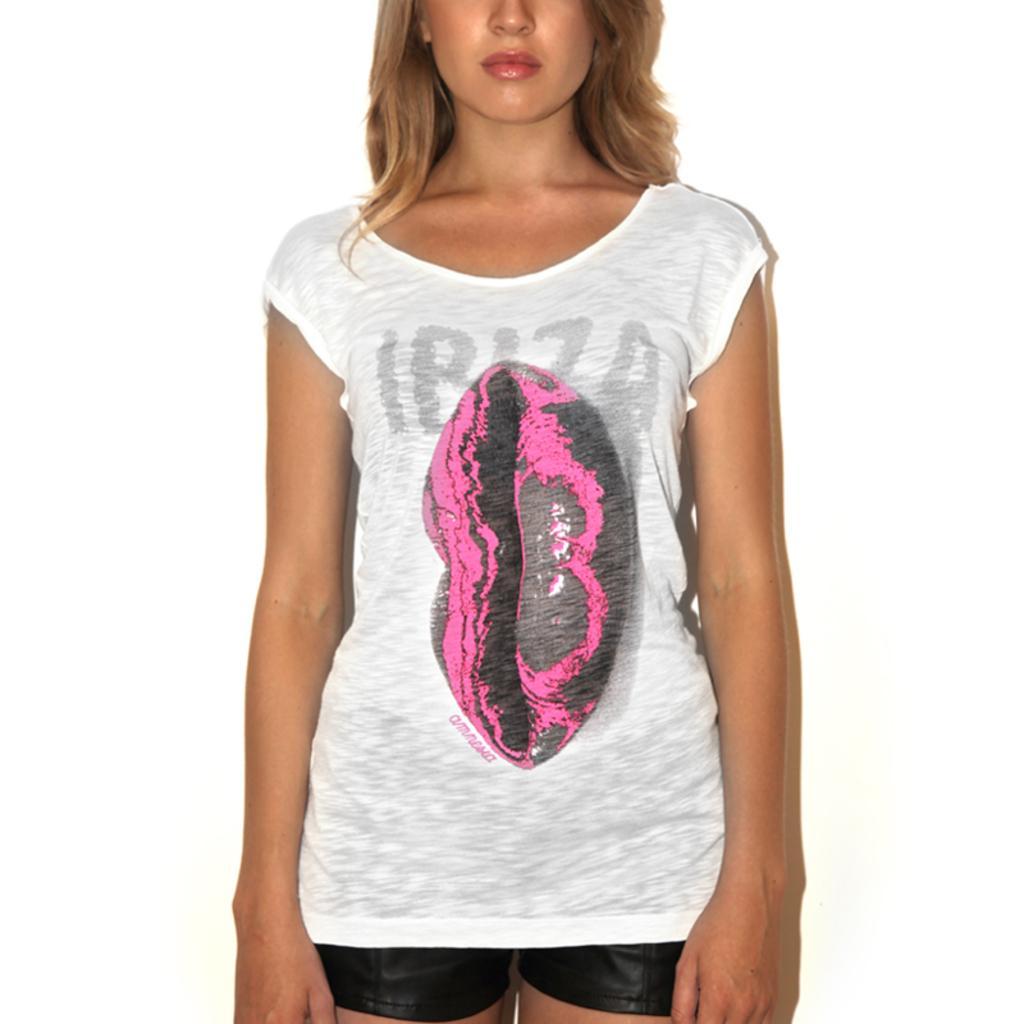Describe this image in one or two sentences. In this picture we can see a woman standing and in the background it is in white color. 